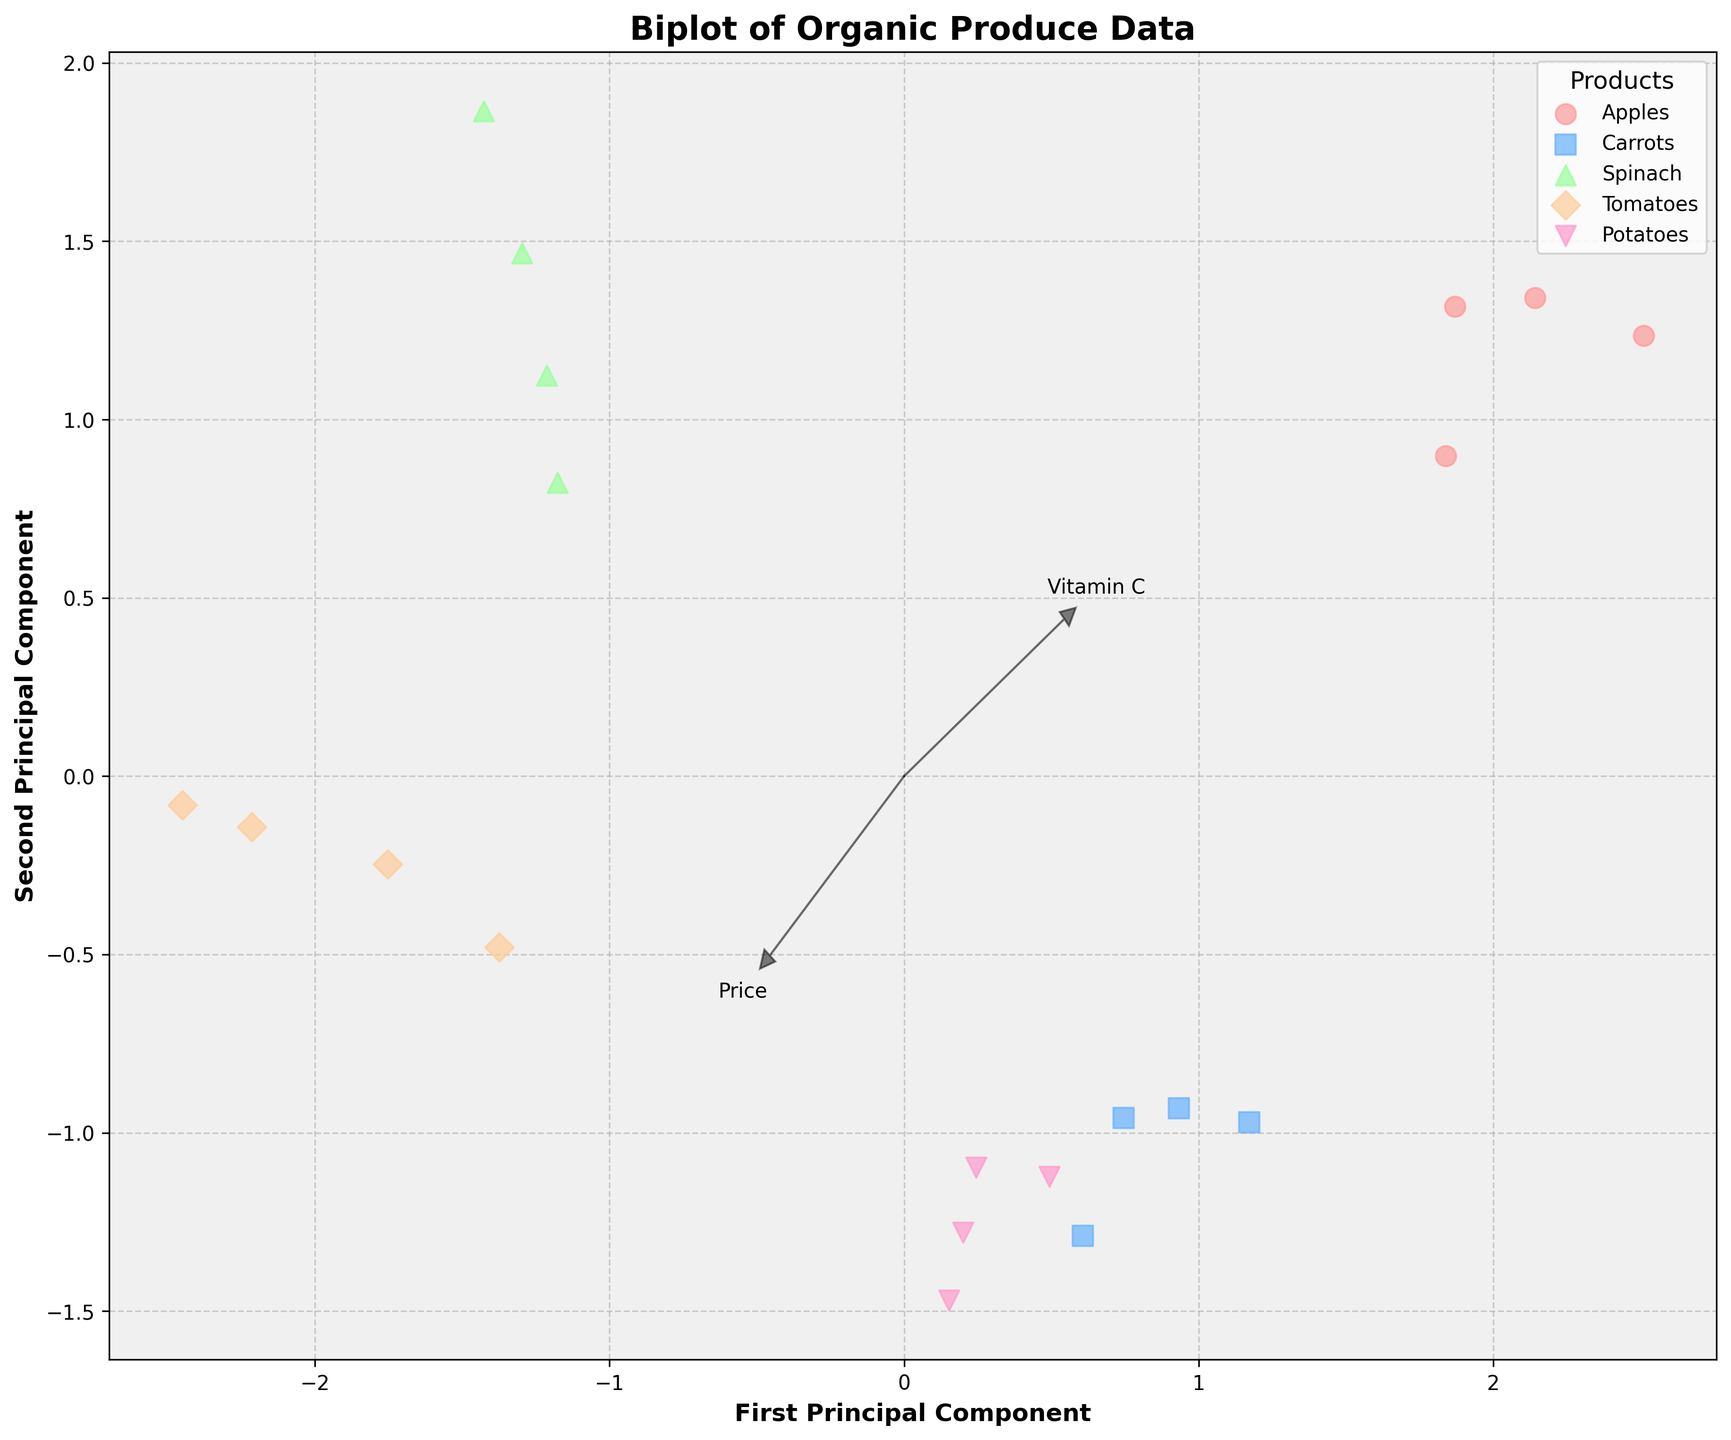What is the title of the figure? The title is typically written at the top of the figure, and it conveys the main topic of the graph.
Answer: Biplot of Organic Produce Data Which product is represented by red circles? Different colors and markers represent different products. Red circles represent one specific product.
Answer: Apples How many distinct products are shown in the plot? By counting the number of unique labels in the legend box, we can determine the number of distinct products displayed.
Answer: 5 Which feature has the highest loading on the first principal component? The feature vectors (arrows) on the plot indicate the loadings. The one with the longest projection on the x-axis has the highest loading on the first principal component.
Answer: Fiber In which season do tomatoes appear closer to the center of the plot? By observing the position of tomato data points and noting their relative distance to the center, we can identify the season.
Answer: Winter What are the x-axis and y-axis labels? The labels for the axes are usually found near the ends of the axes, describing what each axis represents.
Answer: First Principal Component (x-axis), Second Principal Component (y-axis) Which product has data points most scattered along the second principal component? Products with data points spread widely along the y-axis (second principal component) show more variation in this dimension.
Answer: Spinach Which feature vectors (arrows) seem to be the longest? By visually comparing the lengths of the feature vectors, we can identify the longest ones.
Answer: Fiber and Antioxidants Which season shows the highest variability in apple prices based on the data points spread along the first principal component? The spread of apple data points along the x-axis (first principal component) indicates the variability in prices across different seasons.
Answer: Autumn How does the variation in vitamin C content for tomatoes compare across seasons? By analyzing the positions of tomato data points along the arrow representing Vitamin C, we can assess variations between them.
Answer: Significant variation, highest in Summer 